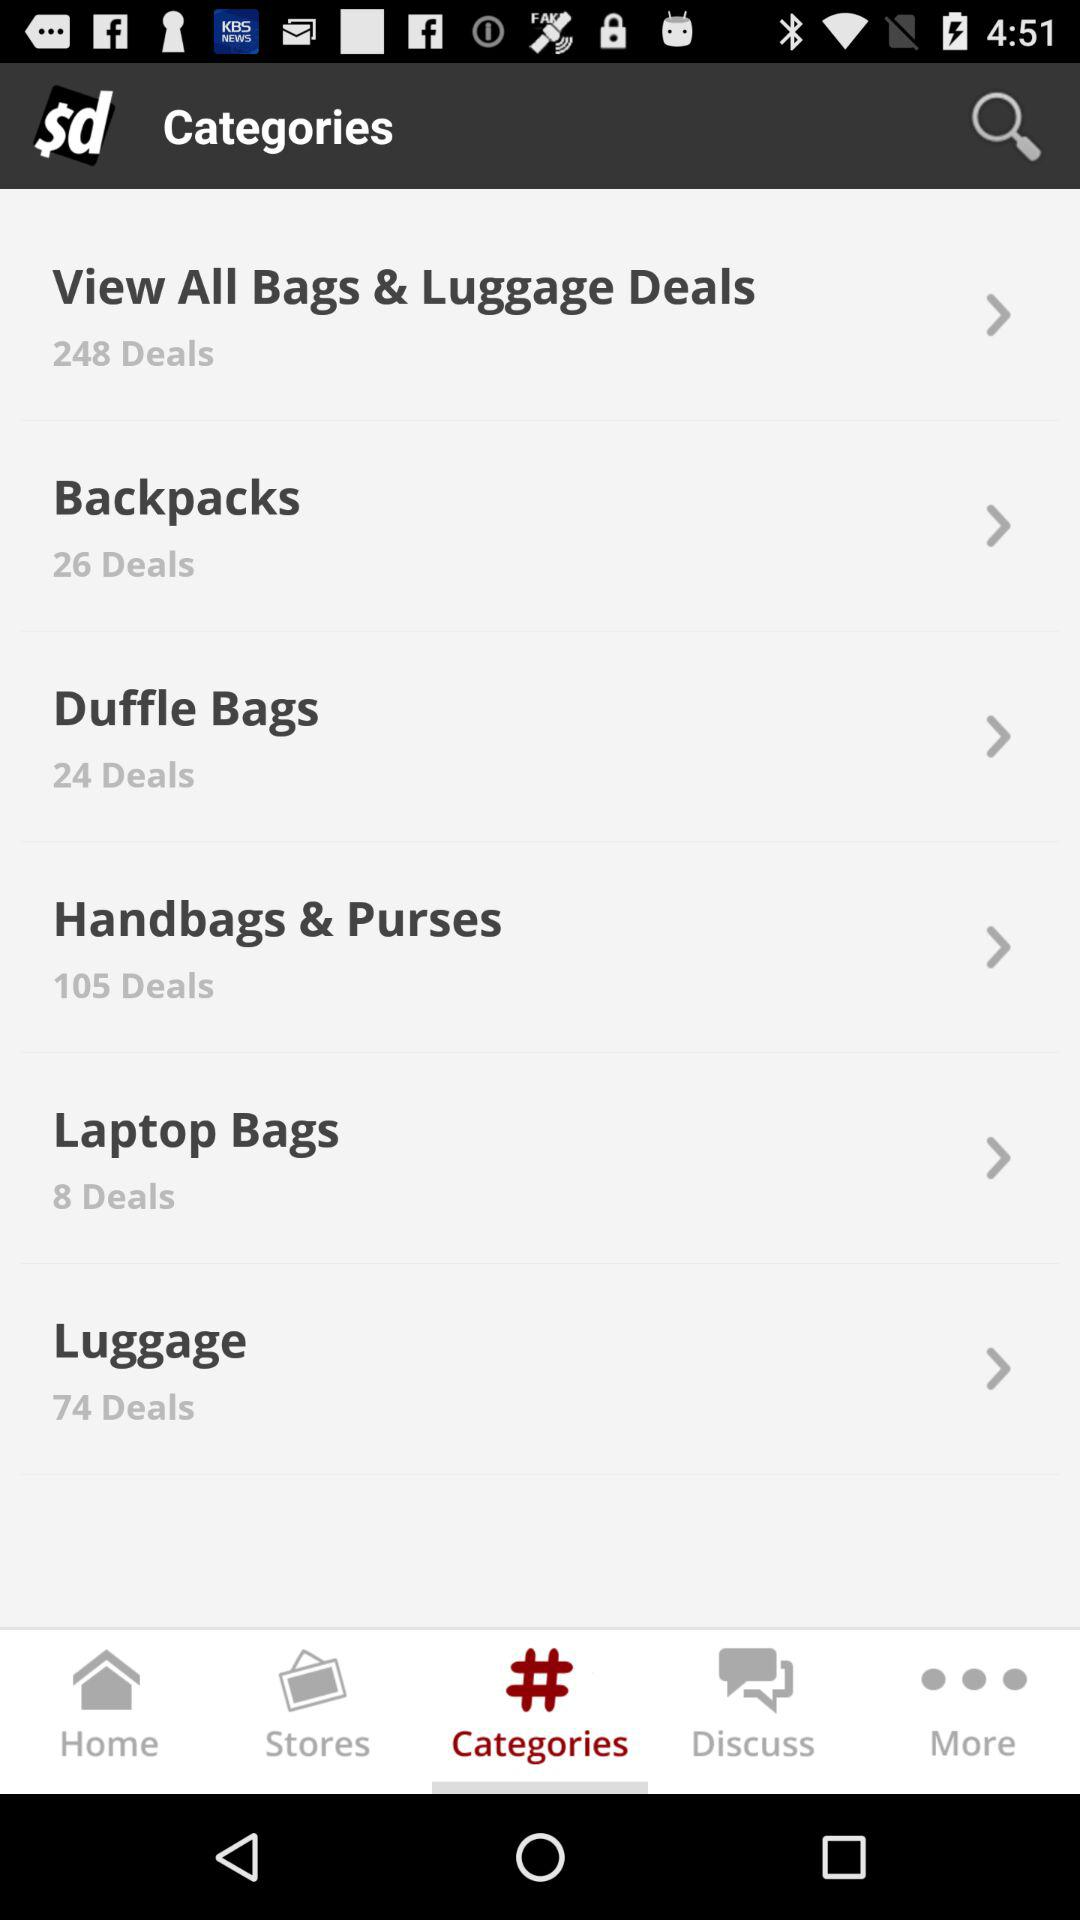What is the number of deals for backpacks? There are 26 deals for backpacks. 